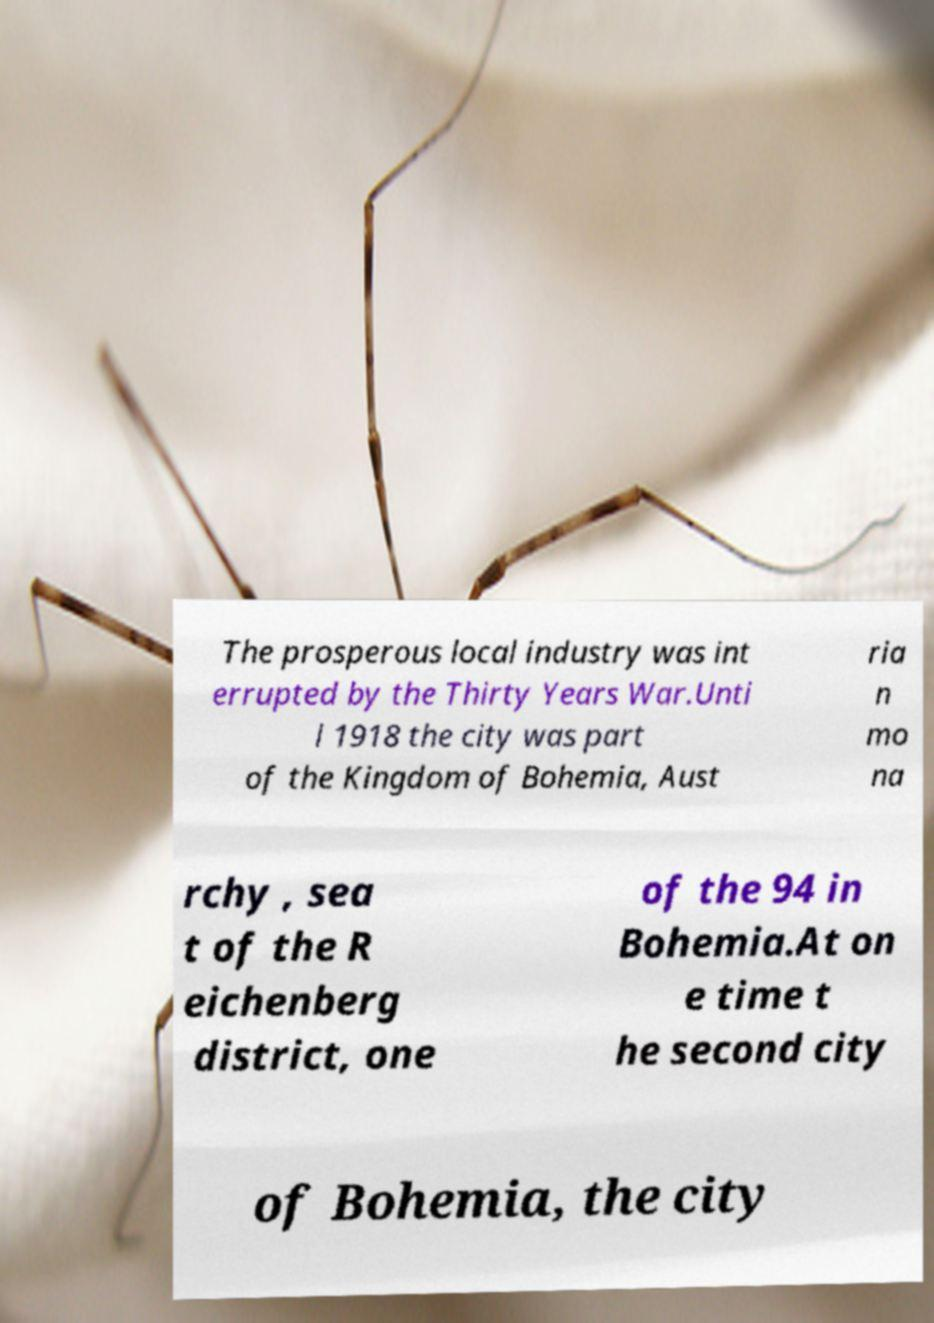Can you read and provide the text displayed in the image?This photo seems to have some interesting text. Can you extract and type it out for me? The prosperous local industry was int errupted by the Thirty Years War.Unti l 1918 the city was part of the Kingdom of Bohemia, Aust ria n mo na rchy , sea t of the R eichenberg district, one of the 94 in Bohemia.At on e time t he second city of Bohemia, the city 